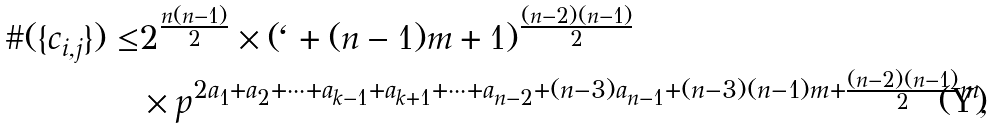Convert formula to latex. <formula><loc_0><loc_0><loc_500><loc_500>\# ( \{ c _ { i , j } \} ) \leq & 2 ^ { \frac { n ( n - 1 ) } { 2 } } \times ( \ell + ( n - 1 ) m + 1 ) ^ { \frac { ( n - 2 ) ( n - 1 ) } { 2 } } \\ & \times p ^ { 2 a _ { 1 } + a _ { 2 } + \cdots + a _ { k - 1 } + a _ { k + 1 } + \cdots + a _ { n - 2 } + ( n - 3 ) a _ { n - 1 } + ( n - 3 ) ( n - 1 ) m + \frac { ( n - 2 ) ( n - 1 ) } { 2 } m } ,</formula> 